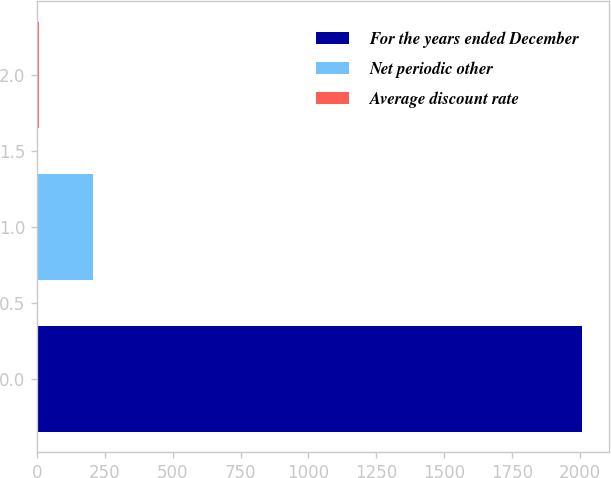Convert chart. <chart><loc_0><loc_0><loc_500><loc_500><bar_chart><fcel>For the years ended December<fcel>Net periodic other<fcel>Average discount rate<nl><fcel>2008<fcel>206.47<fcel>6.3<nl></chart> 